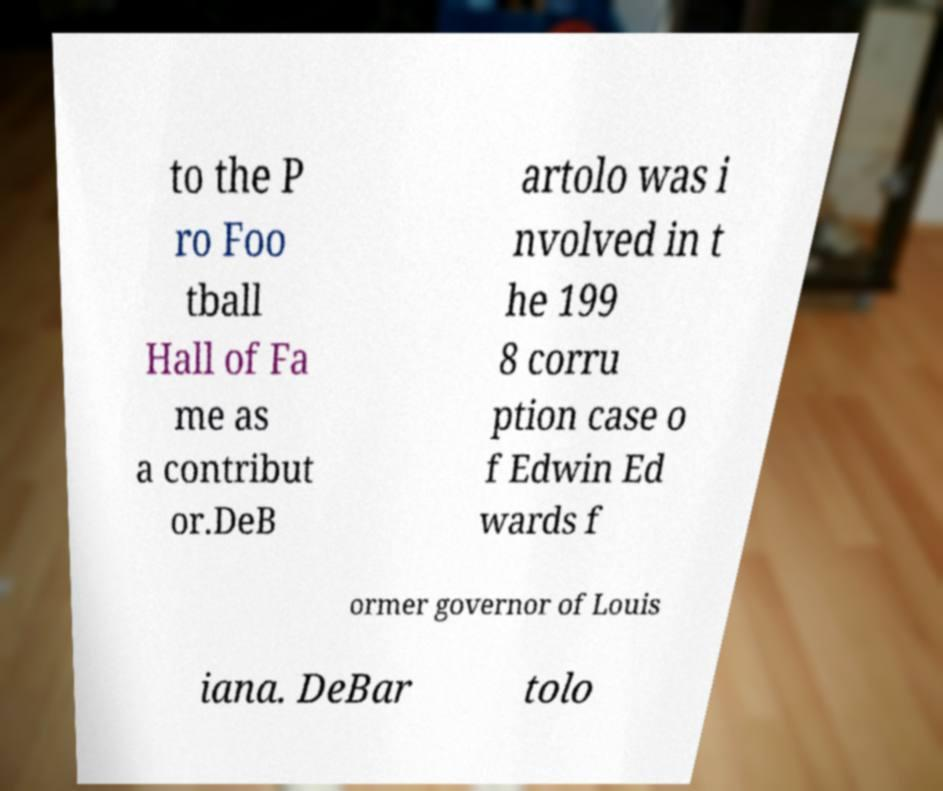Could you extract and type out the text from this image? to the P ro Foo tball Hall of Fa me as a contribut or.DeB artolo was i nvolved in t he 199 8 corru ption case o f Edwin Ed wards f ormer governor of Louis iana. DeBar tolo 